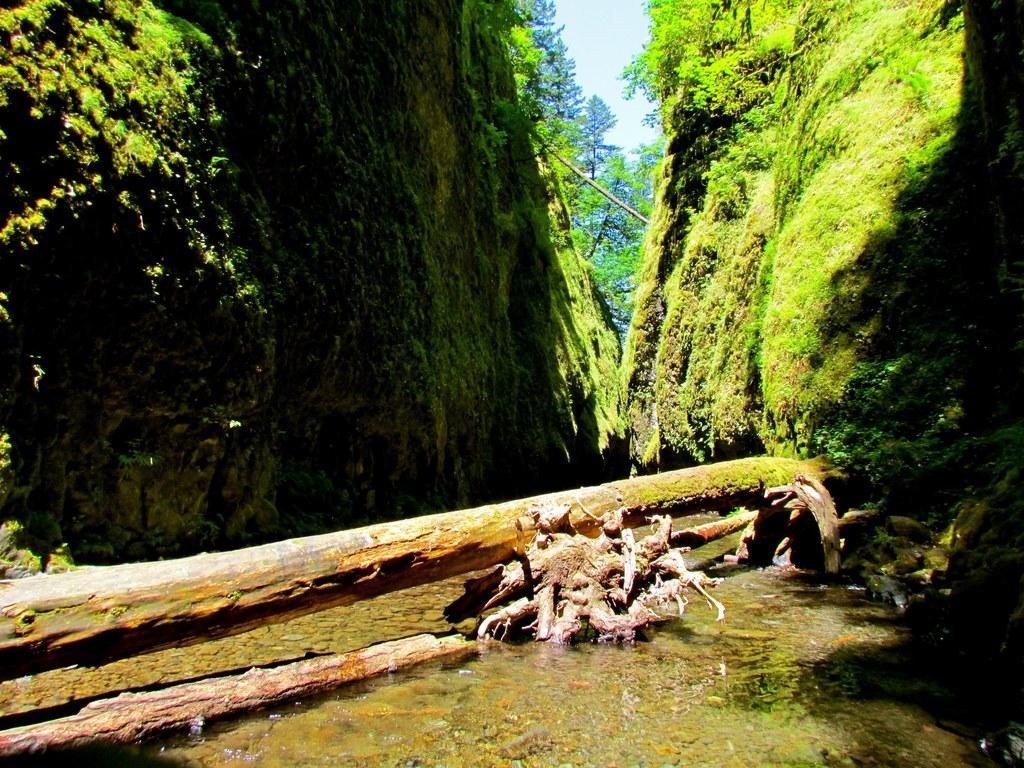In one or two sentences, can you explain what this image depicts? In front of the image there is water. There are trunks of a tree. There is grass on the rocks. In the background of the image there are trees and sky. 